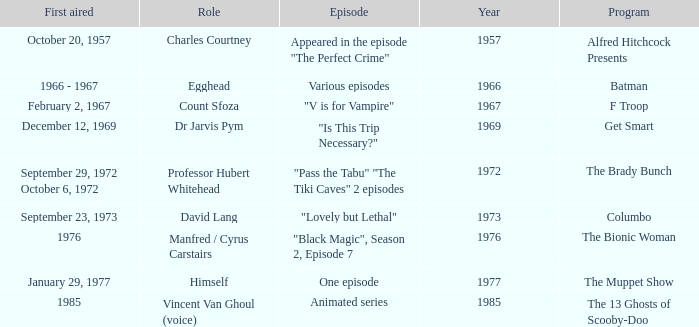What's the first aired date of the Animated Series episode? 1985.0. 